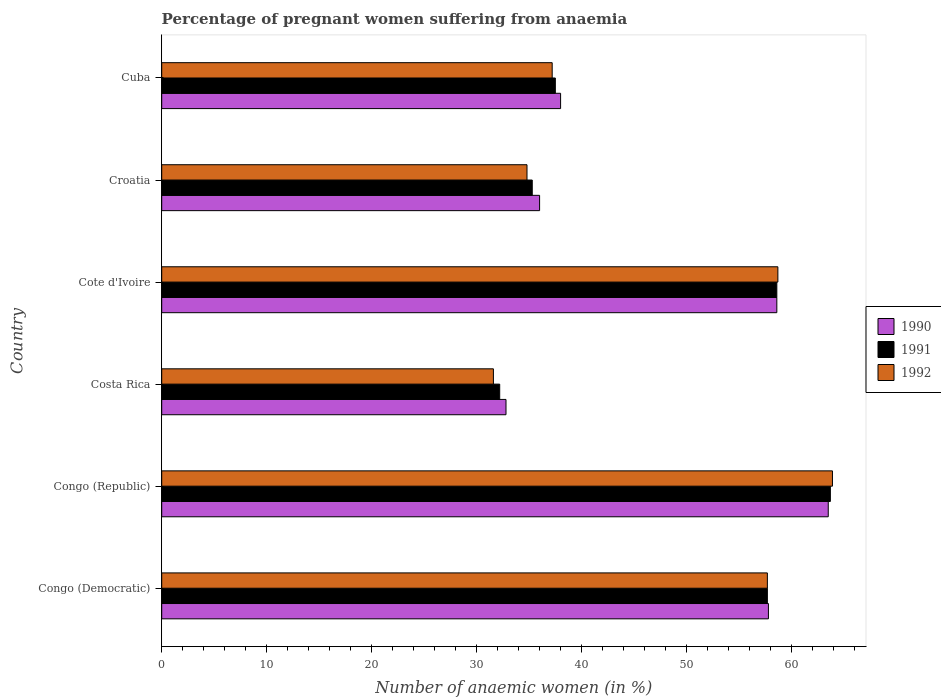How many bars are there on the 6th tick from the top?
Give a very brief answer. 3. What is the label of the 1st group of bars from the top?
Offer a terse response. Cuba. What is the number of anaemic women in 1991 in Cote d'Ivoire?
Give a very brief answer. 58.6. Across all countries, what is the maximum number of anaemic women in 1990?
Offer a terse response. 63.5. Across all countries, what is the minimum number of anaemic women in 1992?
Provide a short and direct response. 31.6. In which country was the number of anaemic women in 1990 maximum?
Give a very brief answer. Congo (Republic). What is the total number of anaemic women in 1991 in the graph?
Keep it short and to the point. 285. What is the difference between the number of anaemic women in 1990 in Cote d'Ivoire and that in Croatia?
Your answer should be very brief. 22.6. What is the difference between the number of anaemic women in 1992 in Congo (Republic) and the number of anaemic women in 1991 in Congo (Democratic)?
Your answer should be compact. 6.2. What is the average number of anaemic women in 1990 per country?
Ensure brevity in your answer.  47.78. What is the difference between the number of anaemic women in 1991 and number of anaemic women in 1992 in Costa Rica?
Ensure brevity in your answer.  0.6. In how many countries, is the number of anaemic women in 1990 greater than 46 %?
Your answer should be compact. 3. What is the ratio of the number of anaemic women in 1992 in Congo (Republic) to that in Cote d'Ivoire?
Offer a terse response. 1.09. Is the number of anaemic women in 1990 in Cote d'Ivoire less than that in Cuba?
Make the answer very short. No. Is the difference between the number of anaemic women in 1991 in Congo (Republic) and Croatia greater than the difference between the number of anaemic women in 1992 in Congo (Republic) and Croatia?
Your response must be concise. No. What is the difference between the highest and the second highest number of anaemic women in 1992?
Give a very brief answer. 5.2. What is the difference between the highest and the lowest number of anaemic women in 1992?
Give a very brief answer. 32.3. In how many countries, is the number of anaemic women in 1992 greater than the average number of anaemic women in 1992 taken over all countries?
Ensure brevity in your answer.  3. What does the 3rd bar from the bottom in Congo (Republic) represents?
Offer a very short reply. 1992. Is it the case that in every country, the sum of the number of anaemic women in 1991 and number of anaemic women in 1992 is greater than the number of anaemic women in 1990?
Provide a succinct answer. Yes. Are the values on the major ticks of X-axis written in scientific E-notation?
Ensure brevity in your answer.  No. Does the graph contain grids?
Offer a terse response. No. Where does the legend appear in the graph?
Give a very brief answer. Center right. How many legend labels are there?
Your answer should be very brief. 3. How are the legend labels stacked?
Give a very brief answer. Vertical. What is the title of the graph?
Ensure brevity in your answer.  Percentage of pregnant women suffering from anaemia. Does "1992" appear as one of the legend labels in the graph?
Offer a terse response. Yes. What is the label or title of the X-axis?
Provide a succinct answer. Number of anaemic women (in %). What is the label or title of the Y-axis?
Make the answer very short. Country. What is the Number of anaemic women (in %) in 1990 in Congo (Democratic)?
Your response must be concise. 57.8. What is the Number of anaemic women (in %) in 1991 in Congo (Democratic)?
Ensure brevity in your answer.  57.7. What is the Number of anaemic women (in %) in 1992 in Congo (Democratic)?
Give a very brief answer. 57.7. What is the Number of anaemic women (in %) in 1990 in Congo (Republic)?
Offer a terse response. 63.5. What is the Number of anaemic women (in %) in 1991 in Congo (Republic)?
Ensure brevity in your answer.  63.7. What is the Number of anaemic women (in %) in 1992 in Congo (Republic)?
Keep it short and to the point. 63.9. What is the Number of anaemic women (in %) in 1990 in Costa Rica?
Provide a short and direct response. 32.8. What is the Number of anaemic women (in %) in 1991 in Costa Rica?
Make the answer very short. 32.2. What is the Number of anaemic women (in %) in 1992 in Costa Rica?
Provide a short and direct response. 31.6. What is the Number of anaemic women (in %) of 1990 in Cote d'Ivoire?
Your answer should be very brief. 58.6. What is the Number of anaemic women (in %) of 1991 in Cote d'Ivoire?
Make the answer very short. 58.6. What is the Number of anaemic women (in %) in 1992 in Cote d'Ivoire?
Your answer should be very brief. 58.7. What is the Number of anaemic women (in %) in 1990 in Croatia?
Your answer should be very brief. 36. What is the Number of anaemic women (in %) of 1991 in Croatia?
Your response must be concise. 35.3. What is the Number of anaemic women (in %) of 1992 in Croatia?
Your answer should be compact. 34.8. What is the Number of anaemic women (in %) of 1991 in Cuba?
Offer a terse response. 37.5. What is the Number of anaemic women (in %) of 1992 in Cuba?
Provide a succinct answer. 37.2. Across all countries, what is the maximum Number of anaemic women (in %) of 1990?
Your response must be concise. 63.5. Across all countries, what is the maximum Number of anaemic women (in %) of 1991?
Keep it short and to the point. 63.7. Across all countries, what is the maximum Number of anaemic women (in %) of 1992?
Ensure brevity in your answer.  63.9. Across all countries, what is the minimum Number of anaemic women (in %) in 1990?
Ensure brevity in your answer.  32.8. Across all countries, what is the minimum Number of anaemic women (in %) of 1991?
Give a very brief answer. 32.2. Across all countries, what is the minimum Number of anaemic women (in %) in 1992?
Offer a terse response. 31.6. What is the total Number of anaemic women (in %) in 1990 in the graph?
Make the answer very short. 286.7. What is the total Number of anaemic women (in %) of 1991 in the graph?
Offer a terse response. 285. What is the total Number of anaemic women (in %) of 1992 in the graph?
Your answer should be compact. 283.9. What is the difference between the Number of anaemic women (in %) of 1990 in Congo (Democratic) and that in Congo (Republic)?
Provide a succinct answer. -5.7. What is the difference between the Number of anaemic women (in %) in 1992 in Congo (Democratic) and that in Congo (Republic)?
Keep it short and to the point. -6.2. What is the difference between the Number of anaemic women (in %) in 1990 in Congo (Democratic) and that in Costa Rica?
Provide a succinct answer. 25. What is the difference between the Number of anaemic women (in %) in 1991 in Congo (Democratic) and that in Costa Rica?
Provide a short and direct response. 25.5. What is the difference between the Number of anaemic women (in %) of 1992 in Congo (Democratic) and that in Costa Rica?
Your answer should be compact. 26.1. What is the difference between the Number of anaemic women (in %) in 1990 in Congo (Democratic) and that in Cote d'Ivoire?
Provide a short and direct response. -0.8. What is the difference between the Number of anaemic women (in %) in 1991 in Congo (Democratic) and that in Cote d'Ivoire?
Provide a short and direct response. -0.9. What is the difference between the Number of anaemic women (in %) of 1990 in Congo (Democratic) and that in Croatia?
Provide a succinct answer. 21.8. What is the difference between the Number of anaemic women (in %) of 1991 in Congo (Democratic) and that in Croatia?
Provide a short and direct response. 22.4. What is the difference between the Number of anaemic women (in %) in 1992 in Congo (Democratic) and that in Croatia?
Make the answer very short. 22.9. What is the difference between the Number of anaemic women (in %) of 1990 in Congo (Democratic) and that in Cuba?
Offer a very short reply. 19.8. What is the difference between the Number of anaemic women (in %) of 1991 in Congo (Democratic) and that in Cuba?
Your answer should be very brief. 20.2. What is the difference between the Number of anaemic women (in %) of 1992 in Congo (Democratic) and that in Cuba?
Your answer should be compact. 20.5. What is the difference between the Number of anaemic women (in %) in 1990 in Congo (Republic) and that in Costa Rica?
Your response must be concise. 30.7. What is the difference between the Number of anaemic women (in %) of 1991 in Congo (Republic) and that in Costa Rica?
Your answer should be very brief. 31.5. What is the difference between the Number of anaemic women (in %) in 1992 in Congo (Republic) and that in Costa Rica?
Make the answer very short. 32.3. What is the difference between the Number of anaemic women (in %) in 1990 in Congo (Republic) and that in Cote d'Ivoire?
Keep it short and to the point. 4.9. What is the difference between the Number of anaemic women (in %) of 1992 in Congo (Republic) and that in Cote d'Ivoire?
Offer a very short reply. 5.2. What is the difference between the Number of anaemic women (in %) of 1990 in Congo (Republic) and that in Croatia?
Make the answer very short. 27.5. What is the difference between the Number of anaemic women (in %) in 1991 in Congo (Republic) and that in Croatia?
Your answer should be very brief. 28.4. What is the difference between the Number of anaemic women (in %) in 1992 in Congo (Republic) and that in Croatia?
Offer a terse response. 29.1. What is the difference between the Number of anaemic women (in %) of 1991 in Congo (Republic) and that in Cuba?
Your answer should be compact. 26.2. What is the difference between the Number of anaemic women (in %) of 1992 in Congo (Republic) and that in Cuba?
Make the answer very short. 26.7. What is the difference between the Number of anaemic women (in %) in 1990 in Costa Rica and that in Cote d'Ivoire?
Provide a short and direct response. -25.8. What is the difference between the Number of anaemic women (in %) of 1991 in Costa Rica and that in Cote d'Ivoire?
Give a very brief answer. -26.4. What is the difference between the Number of anaemic women (in %) in 1992 in Costa Rica and that in Cote d'Ivoire?
Give a very brief answer. -27.1. What is the difference between the Number of anaemic women (in %) of 1991 in Costa Rica and that in Croatia?
Give a very brief answer. -3.1. What is the difference between the Number of anaemic women (in %) of 1991 in Costa Rica and that in Cuba?
Offer a very short reply. -5.3. What is the difference between the Number of anaemic women (in %) in 1992 in Costa Rica and that in Cuba?
Offer a very short reply. -5.6. What is the difference between the Number of anaemic women (in %) of 1990 in Cote d'Ivoire and that in Croatia?
Offer a very short reply. 22.6. What is the difference between the Number of anaemic women (in %) in 1991 in Cote d'Ivoire and that in Croatia?
Make the answer very short. 23.3. What is the difference between the Number of anaemic women (in %) of 1992 in Cote d'Ivoire and that in Croatia?
Offer a terse response. 23.9. What is the difference between the Number of anaemic women (in %) of 1990 in Cote d'Ivoire and that in Cuba?
Make the answer very short. 20.6. What is the difference between the Number of anaemic women (in %) of 1991 in Cote d'Ivoire and that in Cuba?
Offer a terse response. 21.1. What is the difference between the Number of anaemic women (in %) of 1990 in Croatia and that in Cuba?
Your response must be concise. -2. What is the difference between the Number of anaemic women (in %) in 1992 in Croatia and that in Cuba?
Keep it short and to the point. -2.4. What is the difference between the Number of anaemic women (in %) in 1990 in Congo (Democratic) and the Number of anaemic women (in %) in 1991 in Congo (Republic)?
Provide a short and direct response. -5.9. What is the difference between the Number of anaemic women (in %) of 1990 in Congo (Democratic) and the Number of anaemic women (in %) of 1992 in Congo (Republic)?
Keep it short and to the point. -6.1. What is the difference between the Number of anaemic women (in %) of 1991 in Congo (Democratic) and the Number of anaemic women (in %) of 1992 in Congo (Republic)?
Provide a short and direct response. -6.2. What is the difference between the Number of anaemic women (in %) of 1990 in Congo (Democratic) and the Number of anaemic women (in %) of 1991 in Costa Rica?
Keep it short and to the point. 25.6. What is the difference between the Number of anaemic women (in %) in 1990 in Congo (Democratic) and the Number of anaemic women (in %) in 1992 in Costa Rica?
Your answer should be very brief. 26.2. What is the difference between the Number of anaemic women (in %) of 1991 in Congo (Democratic) and the Number of anaemic women (in %) of 1992 in Costa Rica?
Provide a succinct answer. 26.1. What is the difference between the Number of anaemic women (in %) of 1990 in Congo (Democratic) and the Number of anaemic women (in %) of 1992 in Cote d'Ivoire?
Your answer should be very brief. -0.9. What is the difference between the Number of anaemic women (in %) in 1991 in Congo (Democratic) and the Number of anaemic women (in %) in 1992 in Croatia?
Your answer should be compact. 22.9. What is the difference between the Number of anaemic women (in %) in 1990 in Congo (Democratic) and the Number of anaemic women (in %) in 1991 in Cuba?
Offer a very short reply. 20.3. What is the difference between the Number of anaemic women (in %) of 1990 in Congo (Democratic) and the Number of anaemic women (in %) of 1992 in Cuba?
Provide a succinct answer. 20.6. What is the difference between the Number of anaemic women (in %) in 1991 in Congo (Democratic) and the Number of anaemic women (in %) in 1992 in Cuba?
Your response must be concise. 20.5. What is the difference between the Number of anaemic women (in %) in 1990 in Congo (Republic) and the Number of anaemic women (in %) in 1991 in Costa Rica?
Offer a terse response. 31.3. What is the difference between the Number of anaemic women (in %) of 1990 in Congo (Republic) and the Number of anaemic women (in %) of 1992 in Costa Rica?
Your answer should be very brief. 31.9. What is the difference between the Number of anaemic women (in %) of 1991 in Congo (Republic) and the Number of anaemic women (in %) of 1992 in Costa Rica?
Offer a terse response. 32.1. What is the difference between the Number of anaemic women (in %) in 1990 in Congo (Republic) and the Number of anaemic women (in %) in 1992 in Cote d'Ivoire?
Your answer should be compact. 4.8. What is the difference between the Number of anaemic women (in %) in 1991 in Congo (Republic) and the Number of anaemic women (in %) in 1992 in Cote d'Ivoire?
Your answer should be compact. 5. What is the difference between the Number of anaemic women (in %) in 1990 in Congo (Republic) and the Number of anaemic women (in %) in 1991 in Croatia?
Ensure brevity in your answer.  28.2. What is the difference between the Number of anaemic women (in %) in 1990 in Congo (Republic) and the Number of anaemic women (in %) in 1992 in Croatia?
Provide a succinct answer. 28.7. What is the difference between the Number of anaemic women (in %) of 1991 in Congo (Republic) and the Number of anaemic women (in %) of 1992 in Croatia?
Offer a very short reply. 28.9. What is the difference between the Number of anaemic women (in %) in 1990 in Congo (Republic) and the Number of anaemic women (in %) in 1991 in Cuba?
Ensure brevity in your answer.  26. What is the difference between the Number of anaemic women (in %) in 1990 in Congo (Republic) and the Number of anaemic women (in %) in 1992 in Cuba?
Provide a succinct answer. 26.3. What is the difference between the Number of anaemic women (in %) of 1991 in Congo (Republic) and the Number of anaemic women (in %) of 1992 in Cuba?
Give a very brief answer. 26.5. What is the difference between the Number of anaemic women (in %) in 1990 in Costa Rica and the Number of anaemic women (in %) in 1991 in Cote d'Ivoire?
Make the answer very short. -25.8. What is the difference between the Number of anaemic women (in %) of 1990 in Costa Rica and the Number of anaemic women (in %) of 1992 in Cote d'Ivoire?
Your answer should be compact. -25.9. What is the difference between the Number of anaemic women (in %) of 1991 in Costa Rica and the Number of anaemic women (in %) of 1992 in Cote d'Ivoire?
Provide a succinct answer. -26.5. What is the difference between the Number of anaemic women (in %) of 1990 in Costa Rica and the Number of anaemic women (in %) of 1992 in Croatia?
Keep it short and to the point. -2. What is the difference between the Number of anaemic women (in %) in 1990 in Costa Rica and the Number of anaemic women (in %) in 1991 in Cuba?
Make the answer very short. -4.7. What is the difference between the Number of anaemic women (in %) in 1991 in Costa Rica and the Number of anaemic women (in %) in 1992 in Cuba?
Ensure brevity in your answer.  -5. What is the difference between the Number of anaemic women (in %) in 1990 in Cote d'Ivoire and the Number of anaemic women (in %) in 1991 in Croatia?
Offer a terse response. 23.3. What is the difference between the Number of anaemic women (in %) of 1990 in Cote d'Ivoire and the Number of anaemic women (in %) of 1992 in Croatia?
Offer a very short reply. 23.8. What is the difference between the Number of anaemic women (in %) in 1991 in Cote d'Ivoire and the Number of anaemic women (in %) in 1992 in Croatia?
Make the answer very short. 23.8. What is the difference between the Number of anaemic women (in %) in 1990 in Cote d'Ivoire and the Number of anaemic women (in %) in 1991 in Cuba?
Offer a very short reply. 21.1. What is the difference between the Number of anaemic women (in %) of 1990 in Cote d'Ivoire and the Number of anaemic women (in %) of 1992 in Cuba?
Your answer should be compact. 21.4. What is the difference between the Number of anaemic women (in %) of 1991 in Cote d'Ivoire and the Number of anaemic women (in %) of 1992 in Cuba?
Offer a very short reply. 21.4. What is the difference between the Number of anaemic women (in %) in 1990 in Croatia and the Number of anaemic women (in %) in 1991 in Cuba?
Provide a short and direct response. -1.5. What is the difference between the Number of anaemic women (in %) in 1990 in Croatia and the Number of anaemic women (in %) in 1992 in Cuba?
Provide a short and direct response. -1.2. What is the average Number of anaemic women (in %) in 1990 per country?
Offer a terse response. 47.78. What is the average Number of anaemic women (in %) of 1991 per country?
Provide a succinct answer. 47.5. What is the average Number of anaemic women (in %) of 1992 per country?
Provide a succinct answer. 47.32. What is the difference between the Number of anaemic women (in %) in 1990 and Number of anaemic women (in %) in 1991 in Congo (Democratic)?
Offer a terse response. 0.1. What is the difference between the Number of anaemic women (in %) of 1991 and Number of anaemic women (in %) of 1992 in Congo (Democratic)?
Your response must be concise. 0. What is the difference between the Number of anaemic women (in %) in 1990 and Number of anaemic women (in %) in 1992 in Congo (Republic)?
Offer a terse response. -0.4. What is the difference between the Number of anaemic women (in %) in 1990 and Number of anaemic women (in %) in 1992 in Costa Rica?
Your answer should be very brief. 1.2. What is the difference between the Number of anaemic women (in %) in 1990 and Number of anaemic women (in %) in 1991 in Cote d'Ivoire?
Offer a very short reply. 0. What is the difference between the Number of anaemic women (in %) of 1990 and Number of anaemic women (in %) of 1992 in Croatia?
Offer a very short reply. 1.2. What is the difference between the Number of anaemic women (in %) of 1991 and Number of anaemic women (in %) of 1992 in Croatia?
Offer a terse response. 0.5. What is the difference between the Number of anaemic women (in %) in 1990 and Number of anaemic women (in %) in 1991 in Cuba?
Make the answer very short. 0.5. What is the ratio of the Number of anaemic women (in %) in 1990 in Congo (Democratic) to that in Congo (Republic)?
Your response must be concise. 0.91. What is the ratio of the Number of anaemic women (in %) in 1991 in Congo (Democratic) to that in Congo (Republic)?
Provide a succinct answer. 0.91. What is the ratio of the Number of anaemic women (in %) of 1992 in Congo (Democratic) to that in Congo (Republic)?
Your answer should be compact. 0.9. What is the ratio of the Number of anaemic women (in %) in 1990 in Congo (Democratic) to that in Costa Rica?
Make the answer very short. 1.76. What is the ratio of the Number of anaemic women (in %) of 1991 in Congo (Democratic) to that in Costa Rica?
Provide a succinct answer. 1.79. What is the ratio of the Number of anaemic women (in %) of 1992 in Congo (Democratic) to that in Costa Rica?
Make the answer very short. 1.83. What is the ratio of the Number of anaemic women (in %) in 1990 in Congo (Democratic) to that in Cote d'Ivoire?
Keep it short and to the point. 0.99. What is the ratio of the Number of anaemic women (in %) in 1991 in Congo (Democratic) to that in Cote d'Ivoire?
Provide a succinct answer. 0.98. What is the ratio of the Number of anaemic women (in %) in 1990 in Congo (Democratic) to that in Croatia?
Make the answer very short. 1.61. What is the ratio of the Number of anaemic women (in %) of 1991 in Congo (Democratic) to that in Croatia?
Keep it short and to the point. 1.63. What is the ratio of the Number of anaemic women (in %) of 1992 in Congo (Democratic) to that in Croatia?
Provide a short and direct response. 1.66. What is the ratio of the Number of anaemic women (in %) of 1990 in Congo (Democratic) to that in Cuba?
Offer a terse response. 1.52. What is the ratio of the Number of anaemic women (in %) in 1991 in Congo (Democratic) to that in Cuba?
Keep it short and to the point. 1.54. What is the ratio of the Number of anaemic women (in %) of 1992 in Congo (Democratic) to that in Cuba?
Make the answer very short. 1.55. What is the ratio of the Number of anaemic women (in %) of 1990 in Congo (Republic) to that in Costa Rica?
Your response must be concise. 1.94. What is the ratio of the Number of anaemic women (in %) of 1991 in Congo (Republic) to that in Costa Rica?
Your answer should be very brief. 1.98. What is the ratio of the Number of anaemic women (in %) in 1992 in Congo (Republic) to that in Costa Rica?
Give a very brief answer. 2.02. What is the ratio of the Number of anaemic women (in %) of 1990 in Congo (Republic) to that in Cote d'Ivoire?
Provide a short and direct response. 1.08. What is the ratio of the Number of anaemic women (in %) of 1991 in Congo (Republic) to that in Cote d'Ivoire?
Offer a terse response. 1.09. What is the ratio of the Number of anaemic women (in %) of 1992 in Congo (Republic) to that in Cote d'Ivoire?
Provide a succinct answer. 1.09. What is the ratio of the Number of anaemic women (in %) in 1990 in Congo (Republic) to that in Croatia?
Ensure brevity in your answer.  1.76. What is the ratio of the Number of anaemic women (in %) of 1991 in Congo (Republic) to that in Croatia?
Provide a short and direct response. 1.8. What is the ratio of the Number of anaemic women (in %) in 1992 in Congo (Republic) to that in Croatia?
Provide a succinct answer. 1.84. What is the ratio of the Number of anaemic women (in %) of 1990 in Congo (Republic) to that in Cuba?
Ensure brevity in your answer.  1.67. What is the ratio of the Number of anaemic women (in %) in 1991 in Congo (Republic) to that in Cuba?
Ensure brevity in your answer.  1.7. What is the ratio of the Number of anaemic women (in %) of 1992 in Congo (Republic) to that in Cuba?
Provide a succinct answer. 1.72. What is the ratio of the Number of anaemic women (in %) in 1990 in Costa Rica to that in Cote d'Ivoire?
Make the answer very short. 0.56. What is the ratio of the Number of anaemic women (in %) of 1991 in Costa Rica to that in Cote d'Ivoire?
Your response must be concise. 0.55. What is the ratio of the Number of anaemic women (in %) in 1992 in Costa Rica to that in Cote d'Ivoire?
Ensure brevity in your answer.  0.54. What is the ratio of the Number of anaemic women (in %) of 1990 in Costa Rica to that in Croatia?
Your answer should be very brief. 0.91. What is the ratio of the Number of anaemic women (in %) in 1991 in Costa Rica to that in Croatia?
Your answer should be compact. 0.91. What is the ratio of the Number of anaemic women (in %) of 1992 in Costa Rica to that in Croatia?
Your answer should be compact. 0.91. What is the ratio of the Number of anaemic women (in %) in 1990 in Costa Rica to that in Cuba?
Provide a short and direct response. 0.86. What is the ratio of the Number of anaemic women (in %) in 1991 in Costa Rica to that in Cuba?
Offer a very short reply. 0.86. What is the ratio of the Number of anaemic women (in %) in 1992 in Costa Rica to that in Cuba?
Provide a short and direct response. 0.85. What is the ratio of the Number of anaemic women (in %) of 1990 in Cote d'Ivoire to that in Croatia?
Your answer should be compact. 1.63. What is the ratio of the Number of anaemic women (in %) in 1991 in Cote d'Ivoire to that in Croatia?
Offer a very short reply. 1.66. What is the ratio of the Number of anaemic women (in %) of 1992 in Cote d'Ivoire to that in Croatia?
Keep it short and to the point. 1.69. What is the ratio of the Number of anaemic women (in %) of 1990 in Cote d'Ivoire to that in Cuba?
Provide a short and direct response. 1.54. What is the ratio of the Number of anaemic women (in %) in 1991 in Cote d'Ivoire to that in Cuba?
Offer a terse response. 1.56. What is the ratio of the Number of anaemic women (in %) in 1992 in Cote d'Ivoire to that in Cuba?
Make the answer very short. 1.58. What is the ratio of the Number of anaemic women (in %) in 1991 in Croatia to that in Cuba?
Offer a terse response. 0.94. What is the ratio of the Number of anaemic women (in %) of 1992 in Croatia to that in Cuba?
Offer a very short reply. 0.94. What is the difference between the highest and the second highest Number of anaemic women (in %) in 1990?
Ensure brevity in your answer.  4.9. What is the difference between the highest and the lowest Number of anaemic women (in %) of 1990?
Provide a short and direct response. 30.7. What is the difference between the highest and the lowest Number of anaemic women (in %) in 1991?
Offer a terse response. 31.5. What is the difference between the highest and the lowest Number of anaemic women (in %) in 1992?
Give a very brief answer. 32.3. 